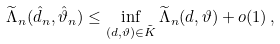<formula> <loc_0><loc_0><loc_500><loc_500>\widetilde { \Lambda } _ { n } ( \hat { d } _ { n } , \hat { \vartheta } _ { n } ) \leq \inf _ { ( d , \vartheta ) \in \tilde { K } } \widetilde { \Lambda } _ { n } ( d , \vartheta ) + o ( 1 ) \, ,</formula> 